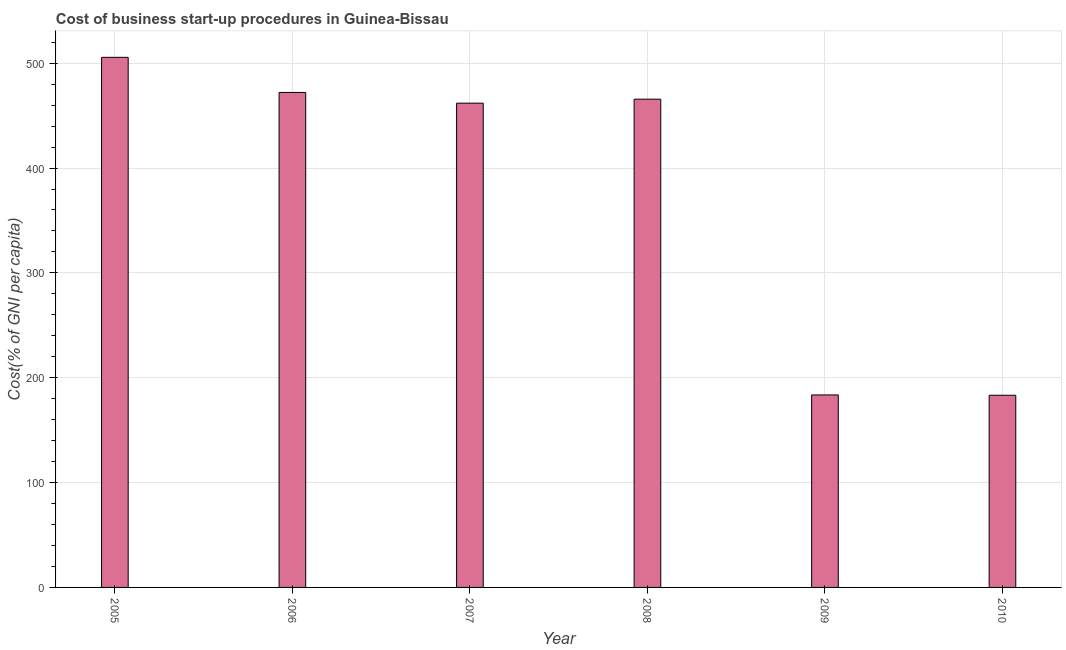Does the graph contain grids?
Your answer should be compact. Yes. What is the title of the graph?
Offer a very short reply. Cost of business start-up procedures in Guinea-Bissau. What is the label or title of the X-axis?
Keep it short and to the point. Year. What is the label or title of the Y-axis?
Provide a short and direct response. Cost(% of GNI per capita). What is the cost of business startup procedures in 2010?
Offer a very short reply. 183.3. Across all years, what is the maximum cost of business startup procedures?
Your answer should be compact. 505.6. Across all years, what is the minimum cost of business startup procedures?
Offer a terse response. 183.3. In which year was the cost of business startup procedures minimum?
Your answer should be compact. 2010. What is the sum of the cost of business startup procedures?
Your answer should be very brief. 2272.2. What is the difference between the cost of business startup procedures in 2005 and 2009?
Offer a terse response. 322. What is the average cost of business startup procedures per year?
Keep it short and to the point. 378.7. What is the median cost of business startup procedures?
Make the answer very short. 463.8. In how many years, is the cost of business startup procedures greater than 240 %?
Provide a short and direct response. 4. Do a majority of the years between 2008 and 2009 (inclusive) have cost of business startup procedures greater than 200 %?
Keep it short and to the point. No. What is the ratio of the cost of business startup procedures in 2005 to that in 2009?
Your answer should be compact. 2.75. Is the cost of business startup procedures in 2007 less than that in 2010?
Give a very brief answer. No. Is the difference between the cost of business startup procedures in 2006 and 2007 greater than the difference between any two years?
Your answer should be very brief. No. What is the difference between the highest and the second highest cost of business startup procedures?
Make the answer very short. 33.5. Is the sum of the cost of business startup procedures in 2005 and 2006 greater than the maximum cost of business startup procedures across all years?
Keep it short and to the point. Yes. What is the difference between the highest and the lowest cost of business startup procedures?
Keep it short and to the point. 322.3. How many years are there in the graph?
Provide a succinct answer. 6. What is the difference between two consecutive major ticks on the Y-axis?
Your answer should be very brief. 100. Are the values on the major ticks of Y-axis written in scientific E-notation?
Ensure brevity in your answer.  No. What is the Cost(% of GNI per capita) of 2005?
Your answer should be compact. 505.6. What is the Cost(% of GNI per capita) in 2006?
Your answer should be very brief. 472.1. What is the Cost(% of GNI per capita) in 2007?
Offer a terse response. 461.9. What is the Cost(% of GNI per capita) in 2008?
Your response must be concise. 465.7. What is the Cost(% of GNI per capita) in 2009?
Your answer should be very brief. 183.6. What is the Cost(% of GNI per capita) in 2010?
Offer a very short reply. 183.3. What is the difference between the Cost(% of GNI per capita) in 2005 and 2006?
Provide a succinct answer. 33.5. What is the difference between the Cost(% of GNI per capita) in 2005 and 2007?
Offer a very short reply. 43.7. What is the difference between the Cost(% of GNI per capita) in 2005 and 2008?
Provide a short and direct response. 39.9. What is the difference between the Cost(% of GNI per capita) in 2005 and 2009?
Keep it short and to the point. 322. What is the difference between the Cost(% of GNI per capita) in 2005 and 2010?
Provide a succinct answer. 322.3. What is the difference between the Cost(% of GNI per capita) in 2006 and 2008?
Give a very brief answer. 6.4. What is the difference between the Cost(% of GNI per capita) in 2006 and 2009?
Provide a short and direct response. 288.5. What is the difference between the Cost(% of GNI per capita) in 2006 and 2010?
Provide a short and direct response. 288.8. What is the difference between the Cost(% of GNI per capita) in 2007 and 2008?
Make the answer very short. -3.8. What is the difference between the Cost(% of GNI per capita) in 2007 and 2009?
Provide a succinct answer. 278.3. What is the difference between the Cost(% of GNI per capita) in 2007 and 2010?
Your answer should be very brief. 278.6. What is the difference between the Cost(% of GNI per capita) in 2008 and 2009?
Your response must be concise. 282.1. What is the difference between the Cost(% of GNI per capita) in 2008 and 2010?
Offer a very short reply. 282.4. What is the difference between the Cost(% of GNI per capita) in 2009 and 2010?
Offer a terse response. 0.3. What is the ratio of the Cost(% of GNI per capita) in 2005 to that in 2006?
Your answer should be very brief. 1.07. What is the ratio of the Cost(% of GNI per capita) in 2005 to that in 2007?
Provide a short and direct response. 1.09. What is the ratio of the Cost(% of GNI per capita) in 2005 to that in 2008?
Your answer should be compact. 1.09. What is the ratio of the Cost(% of GNI per capita) in 2005 to that in 2009?
Ensure brevity in your answer.  2.75. What is the ratio of the Cost(% of GNI per capita) in 2005 to that in 2010?
Your answer should be very brief. 2.76. What is the ratio of the Cost(% of GNI per capita) in 2006 to that in 2009?
Keep it short and to the point. 2.57. What is the ratio of the Cost(% of GNI per capita) in 2006 to that in 2010?
Offer a very short reply. 2.58. What is the ratio of the Cost(% of GNI per capita) in 2007 to that in 2008?
Provide a succinct answer. 0.99. What is the ratio of the Cost(% of GNI per capita) in 2007 to that in 2009?
Give a very brief answer. 2.52. What is the ratio of the Cost(% of GNI per capita) in 2007 to that in 2010?
Keep it short and to the point. 2.52. What is the ratio of the Cost(% of GNI per capita) in 2008 to that in 2009?
Offer a terse response. 2.54. What is the ratio of the Cost(% of GNI per capita) in 2008 to that in 2010?
Give a very brief answer. 2.54. 